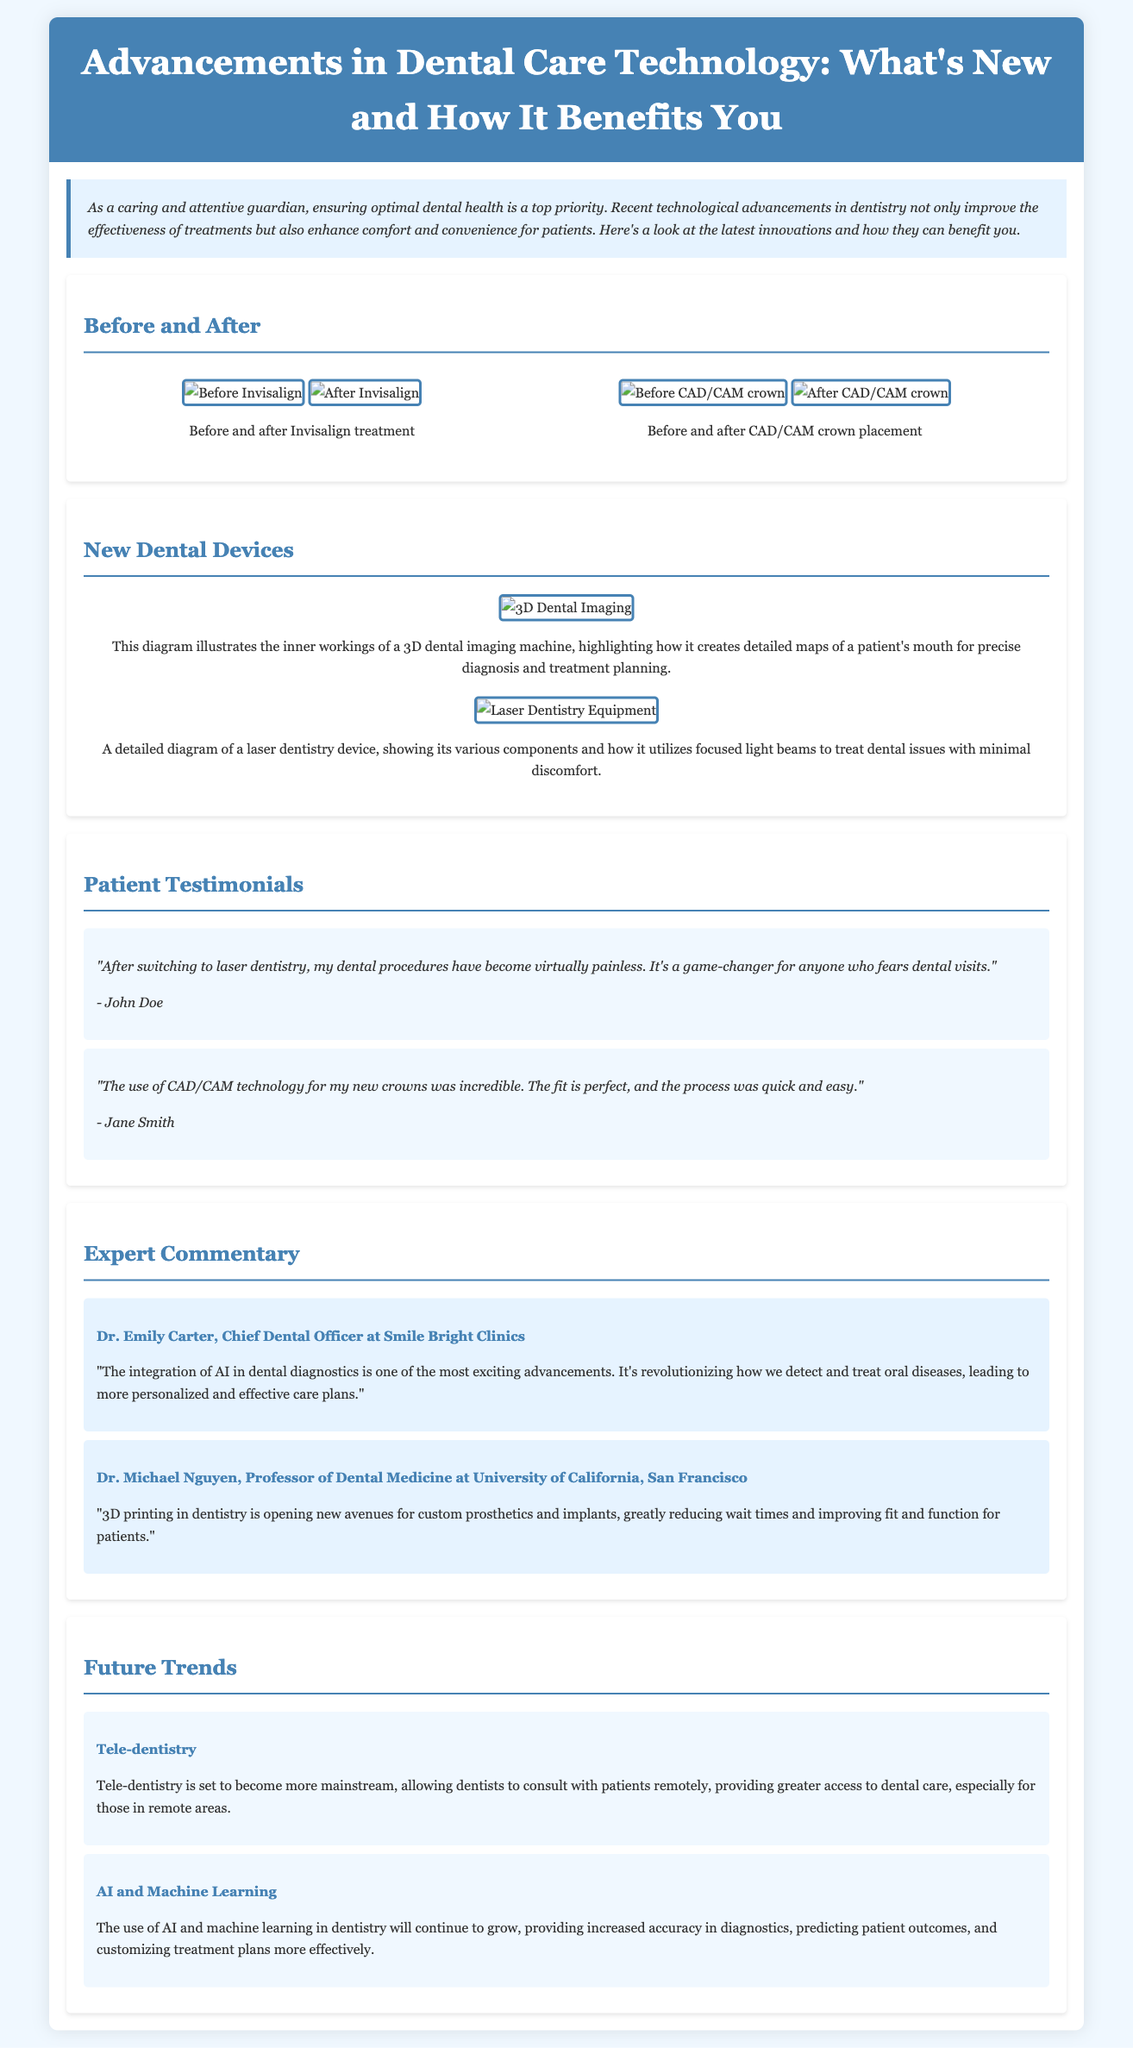What dental treatment is mentioned as virtually painless? The document includes a testimonial stating that laser dentistry makes procedures virtually painless.
Answer: Laser dentistry What is the name of the Chief Dental Officer at Smile Bright Clinics? The expert commentary section identifies Dr. Emily Carter as the Chief Dental Officer.
Answer: Dr. Emily Carter What technology was used for the new crowns that Jane Smith mentions? Jane Smith's testimonial specifically refers to CAD/CAM technology for her new crowns.
Answer: CAD/CAM technology What innovative dental imaging method is highlighted in the document? The document discusses 3D dental imaging as a new method for creating detailed maps of a patient's mouth.
Answer: 3D dental imaging What is one future trend in dental care mentioned in the article? The document states that tele-dentistry is expected to become more mainstream, improving access to dental care.
Answer: Tele-dentistry How many before-and-after photo pairs are featured in the document? The section titled "Before and After" includes two pairs of photos comparing treatments before and after.
Answer: Two What technology does Dr. Michael Nguyen highlight for custom prosthetics? In his commentary, Dr. Michael Nguyen emphasizes the advancements brought by 3D printing in the creation of custom prosthetics.
Answer: 3D printing What is the background color of the testimonial section? The testimonial section has a light blue background color, styled to differentiate it from other sections.
Answer: Light blue 